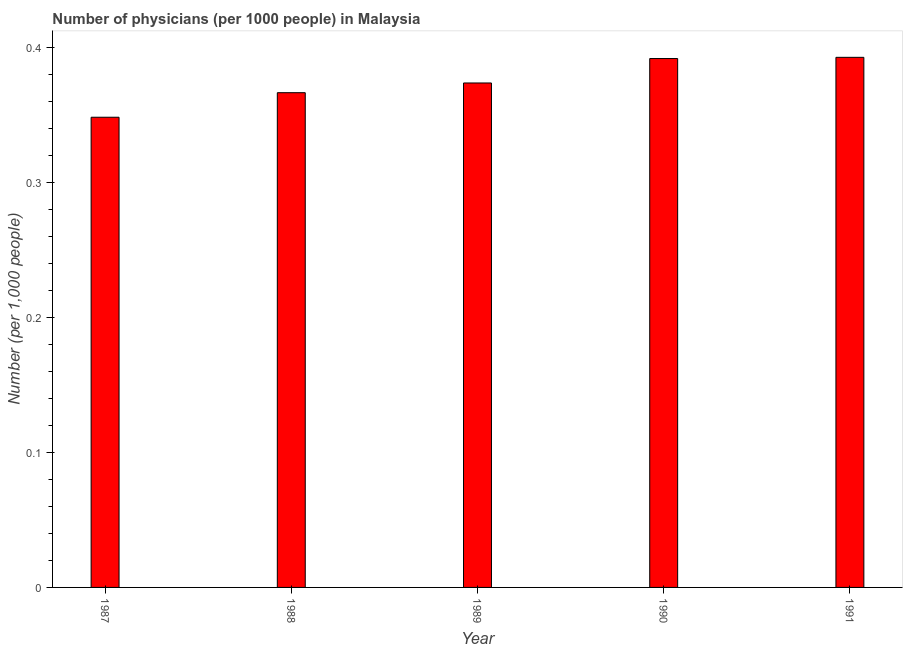Does the graph contain any zero values?
Your response must be concise. No. What is the title of the graph?
Offer a very short reply. Number of physicians (per 1000 people) in Malaysia. What is the label or title of the X-axis?
Your response must be concise. Year. What is the label or title of the Y-axis?
Provide a short and direct response. Number (per 1,0 people). What is the number of physicians in 1989?
Offer a terse response. 0.37. Across all years, what is the maximum number of physicians?
Your answer should be compact. 0.39. Across all years, what is the minimum number of physicians?
Provide a short and direct response. 0.35. In which year was the number of physicians maximum?
Provide a succinct answer. 1991. In which year was the number of physicians minimum?
Offer a very short reply. 1987. What is the sum of the number of physicians?
Your answer should be very brief. 1.87. What is the difference between the number of physicians in 1988 and 1989?
Provide a succinct answer. -0.01. What is the median number of physicians?
Make the answer very short. 0.37. In how many years, is the number of physicians greater than 0.2 ?
Provide a succinct answer. 5. Do a majority of the years between 1988 and 1989 (inclusive) have number of physicians greater than 0.14 ?
Provide a short and direct response. Yes. Is the number of physicians in 1987 less than that in 1989?
Your answer should be compact. Yes. What is the difference between the highest and the lowest number of physicians?
Your answer should be very brief. 0.04. In how many years, is the number of physicians greater than the average number of physicians taken over all years?
Your response must be concise. 2. How many bars are there?
Offer a terse response. 5. Are all the bars in the graph horizontal?
Offer a terse response. No. How many years are there in the graph?
Make the answer very short. 5. What is the Number (per 1,000 people) of 1987?
Your answer should be compact. 0.35. What is the Number (per 1,000 people) of 1988?
Provide a succinct answer. 0.37. What is the Number (per 1,000 people) of 1989?
Make the answer very short. 0.37. What is the Number (per 1,000 people) in 1990?
Your response must be concise. 0.39. What is the Number (per 1,000 people) of 1991?
Offer a very short reply. 0.39. What is the difference between the Number (per 1,000 people) in 1987 and 1988?
Give a very brief answer. -0.02. What is the difference between the Number (per 1,000 people) in 1987 and 1989?
Keep it short and to the point. -0.03. What is the difference between the Number (per 1,000 people) in 1987 and 1990?
Offer a terse response. -0.04. What is the difference between the Number (per 1,000 people) in 1987 and 1991?
Provide a succinct answer. -0.04. What is the difference between the Number (per 1,000 people) in 1988 and 1989?
Offer a very short reply. -0.01. What is the difference between the Number (per 1,000 people) in 1988 and 1990?
Give a very brief answer. -0.03. What is the difference between the Number (per 1,000 people) in 1988 and 1991?
Your response must be concise. -0.03. What is the difference between the Number (per 1,000 people) in 1989 and 1990?
Ensure brevity in your answer.  -0.02. What is the difference between the Number (per 1,000 people) in 1989 and 1991?
Make the answer very short. -0.02. What is the difference between the Number (per 1,000 people) in 1990 and 1991?
Give a very brief answer. -0. What is the ratio of the Number (per 1,000 people) in 1987 to that in 1988?
Keep it short and to the point. 0.95. What is the ratio of the Number (per 1,000 people) in 1987 to that in 1989?
Ensure brevity in your answer.  0.93. What is the ratio of the Number (per 1,000 people) in 1987 to that in 1990?
Your answer should be compact. 0.89. What is the ratio of the Number (per 1,000 people) in 1987 to that in 1991?
Your response must be concise. 0.89. What is the ratio of the Number (per 1,000 people) in 1988 to that in 1989?
Provide a short and direct response. 0.98. What is the ratio of the Number (per 1,000 people) in 1988 to that in 1990?
Your response must be concise. 0.94. What is the ratio of the Number (per 1,000 people) in 1988 to that in 1991?
Keep it short and to the point. 0.93. What is the ratio of the Number (per 1,000 people) in 1989 to that in 1990?
Offer a terse response. 0.95. 